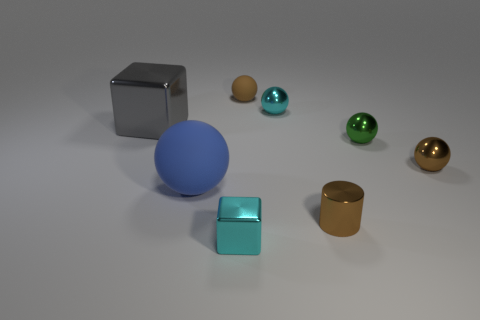There is a cyan metal object that is in front of the large gray thing; what shape is it? cube 